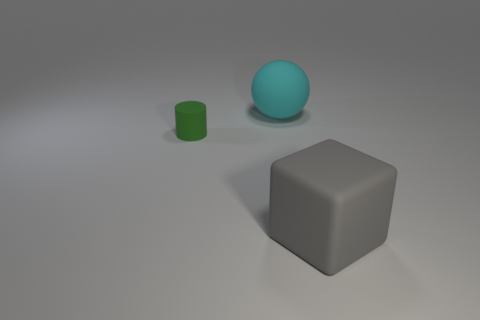Is there any other thing that is made of the same material as the big cyan object?
Provide a short and direct response. Yes. How big is the matte object that is to the left of the large thing that is behind the matte object that is to the left of the cyan object?
Your answer should be very brief. Small. What number of shiny objects are either blue objects or big cyan spheres?
Your answer should be very brief. 0. What size is the ball?
Give a very brief answer. Large. What number of things are either small cylinders or things that are right of the small rubber object?
Provide a short and direct response. 3. Does the cyan ball have the same size as the thing that is in front of the green thing?
Give a very brief answer. Yes. Does the matte thing that is behind the green rubber thing have the same size as the small cylinder?
Provide a short and direct response. No. What number of other things are there of the same material as the cyan thing
Your answer should be compact. 2. Are there an equal number of big gray matte cubes in front of the gray object and tiny matte cylinders in front of the rubber cylinder?
Provide a short and direct response. Yes. The big rubber object that is behind the big object on the right side of the big thing that is behind the tiny green cylinder is what color?
Ensure brevity in your answer.  Cyan. 